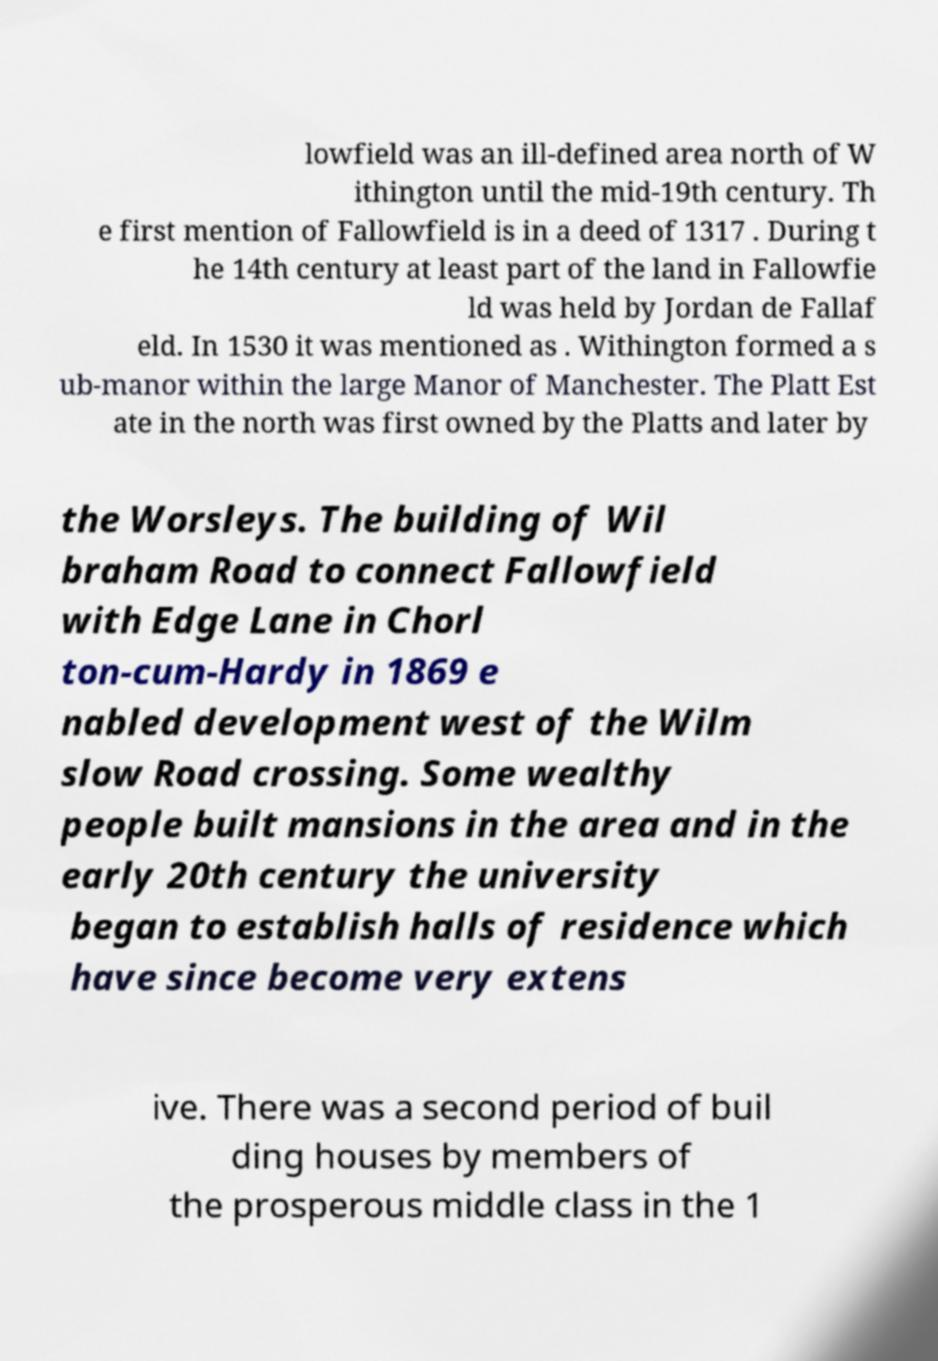What messages or text are displayed in this image? I need them in a readable, typed format. lowfield was an ill-defined area north of W ithington until the mid-19th century. Th e first mention of Fallowfield is in a deed of 1317 . During t he 14th century at least part of the land in Fallowfie ld was held by Jordan de Fallaf eld. In 1530 it was mentioned as . Withington formed a s ub-manor within the large Manor of Manchester. The Platt Est ate in the north was first owned by the Platts and later by the Worsleys. The building of Wil braham Road to connect Fallowfield with Edge Lane in Chorl ton-cum-Hardy in 1869 e nabled development west of the Wilm slow Road crossing. Some wealthy people built mansions in the area and in the early 20th century the university began to establish halls of residence which have since become very extens ive. There was a second period of buil ding houses by members of the prosperous middle class in the 1 